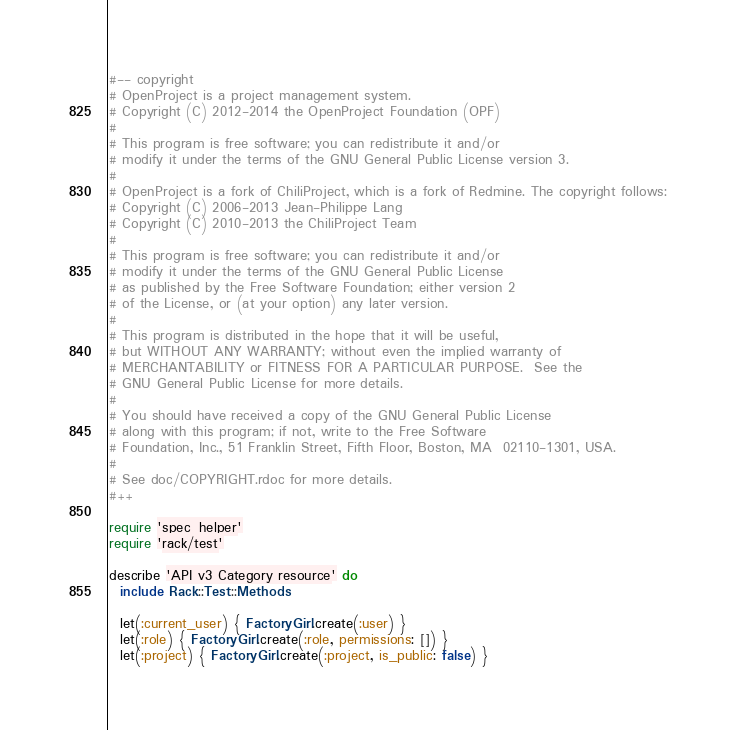Convert code to text. <code><loc_0><loc_0><loc_500><loc_500><_Ruby_>#-- copyright
# OpenProject is a project management system.
# Copyright (C) 2012-2014 the OpenProject Foundation (OPF)
#
# This program is free software; you can redistribute it and/or
# modify it under the terms of the GNU General Public License version 3.
#
# OpenProject is a fork of ChiliProject, which is a fork of Redmine. The copyright follows:
# Copyright (C) 2006-2013 Jean-Philippe Lang
# Copyright (C) 2010-2013 the ChiliProject Team
#
# This program is free software; you can redistribute it and/or
# modify it under the terms of the GNU General Public License
# as published by the Free Software Foundation; either version 2
# of the License, or (at your option) any later version.
#
# This program is distributed in the hope that it will be useful,
# but WITHOUT ANY WARRANTY; without even the implied warranty of
# MERCHANTABILITY or FITNESS FOR A PARTICULAR PURPOSE.  See the
# GNU General Public License for more details.
#
# You should have received a copy of the GNU General Public License
# along with this program; if not, write to the Free Software
# Foundation, Inc., 51 Franklin Street, Fifth Floor, Boston, MA  02110-1301, USA.
#
# See doc/COPYRIGHT.rdoc for more details.
#++

require 'spec_helper'
require 'rack/test'

describe 'API v3 Category resource' do
  include Rack::Test::Methods

  let(:current_user) { FactoryGirl.create(:user) }
  let(:role) { FactoryGirl.create(:role, permissions: []) }
  let(:project) { FactoryGirl.create(:project, is_public: false) }</code> 